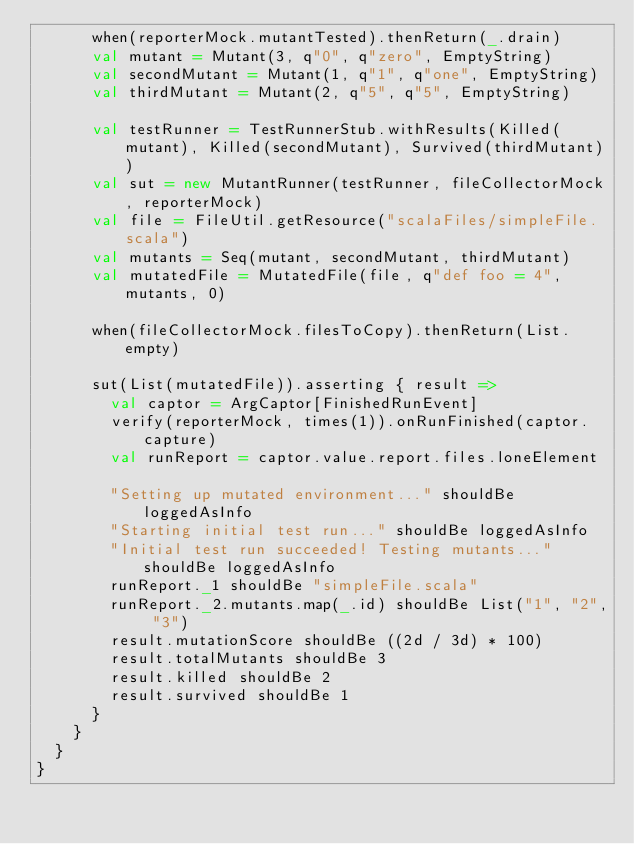Convert code to text. <code><loc_0><loc_0><loc_500><loc_500><_Scala_>      when(reporterMock.mutantTested).thenReturn(_.drain)
      val mutant = Mutant(3, q"0", q"zero", EmptyString)
      val secondMutant = Mutant(1, q"1", q"one", EmptyString)
      val thirdMutant = Mutant(2, q"5", q"5", EmptyString)

      val testRunner = TestRunnerStub.withResults(Killed(mutant), Killed(secondMutant), Survived(thirdMutant))
      val sut = new MutantRunner(testRunner, fileCollectorMock, reporterMock)
      val file = FileUtil.getResource("scalaFiles/simpleFile.scala")
      val mutants = Seq(mutant, secondMutant, thirdMutant)
      val mutatedFile = MutatedFile(file, q"def foo = 4", mutants, 0)

      when(fileCollectorMock.filesToCopy).thenReturn(List.empty)

      sut(List(mutatedFile)).asserting { result =>
        val captor = ArgCaptor[FinishedRunEvent]
        verify(reporterMock, times(1)).onRunFinished(captor.capture)
        val runReport = captor.value.report.files.loneElement

        "Setting up mutated environment..." shouldBe loggedAsInfo
        "Starting initial test run..." shouldBe loggedAsInfo
        "Initial test run succeeded! Testing mutants..." shouldBe loggedAsInfo
        runReport._1 shouldBe "simpleFile.scala"
        runReport._2.mutants.map(_.id) shouldBe List("1", "2", "3")
        result.mutationScore shouldBe ((2d / 3d) * 100)
        result.totalMutants shouldBe 3
        result.killed shouldBe 2
        result.survived shouldBe 1
      }
    }
  }
}
</code> 